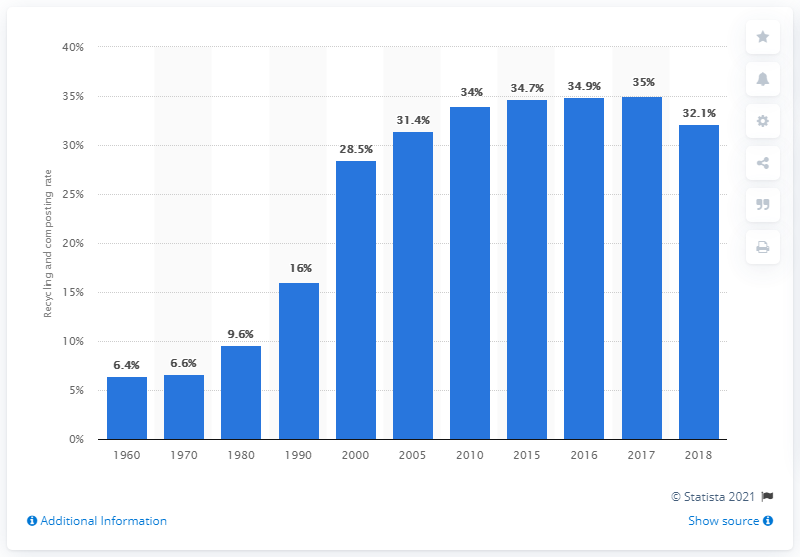Specify some key components in this picture. Recycling in the United States began to slow down in 2005. In 2018, the recycling rate of municipal solid waste in the United States was 32.1%. 